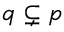<formula> <loc_0><loc_0><loc_500><loc_500>{ \mathfrak { q } } \subsetneq { \mathfrak { p } }</formula> 